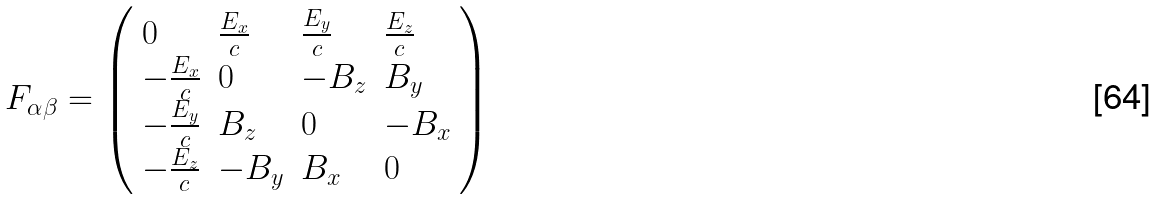<formula> <loc_0><loc_0><loc_500><loc_500>F _ { \alpha \beta } = { \left ( \begin{array} { l l l l } { 0 } & { { \frac { E _ { x } } { c } } } & { { \frac { E _ { y } } { c } } } & { { \frac { E _ { z } } { c } } } \\ { - { \frac { E _ { x } } { c } } } & { 0 } & { - B _ { z } } & { B _ { y } } \\ { - { \frac { E _ { y } } { c } } } & { B _ { z } } & { 0 } & { - B _ { x } } \\ { - { \frac { E _ { z } } { c } } } & { - B _ { y } } & { B _ { x } } & { 0 } \end{array} \right ) }</formula> 